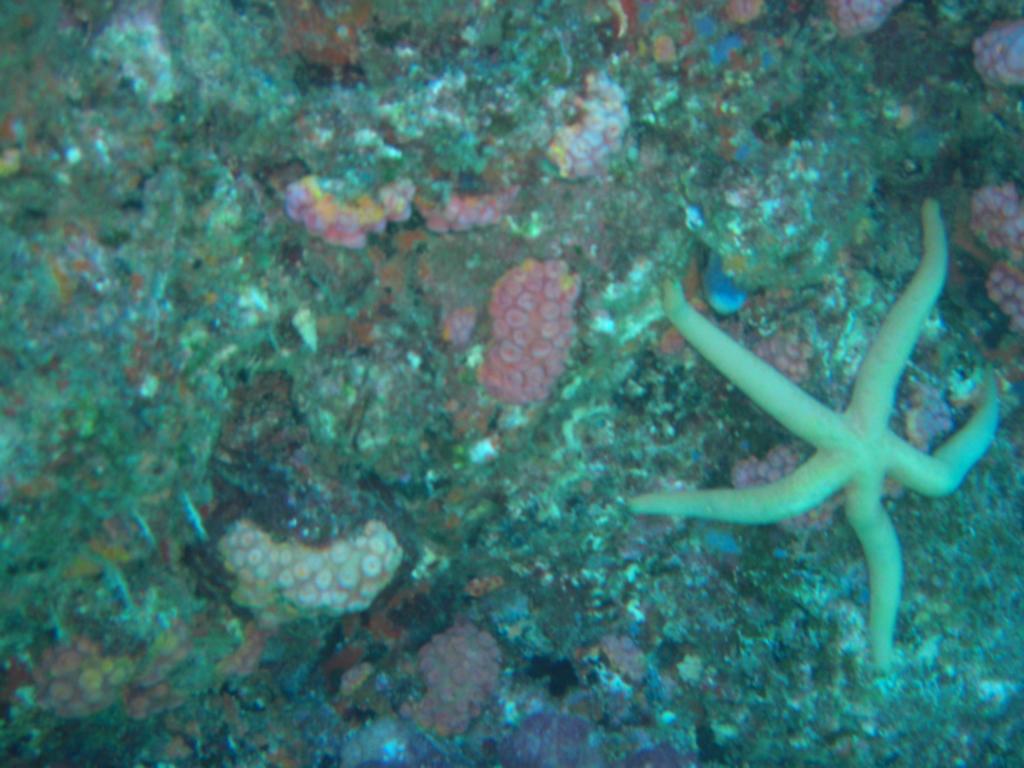Could you give a brief overview of what you see in this image? In this image I can see there is a starfish on the aquatic rock. 